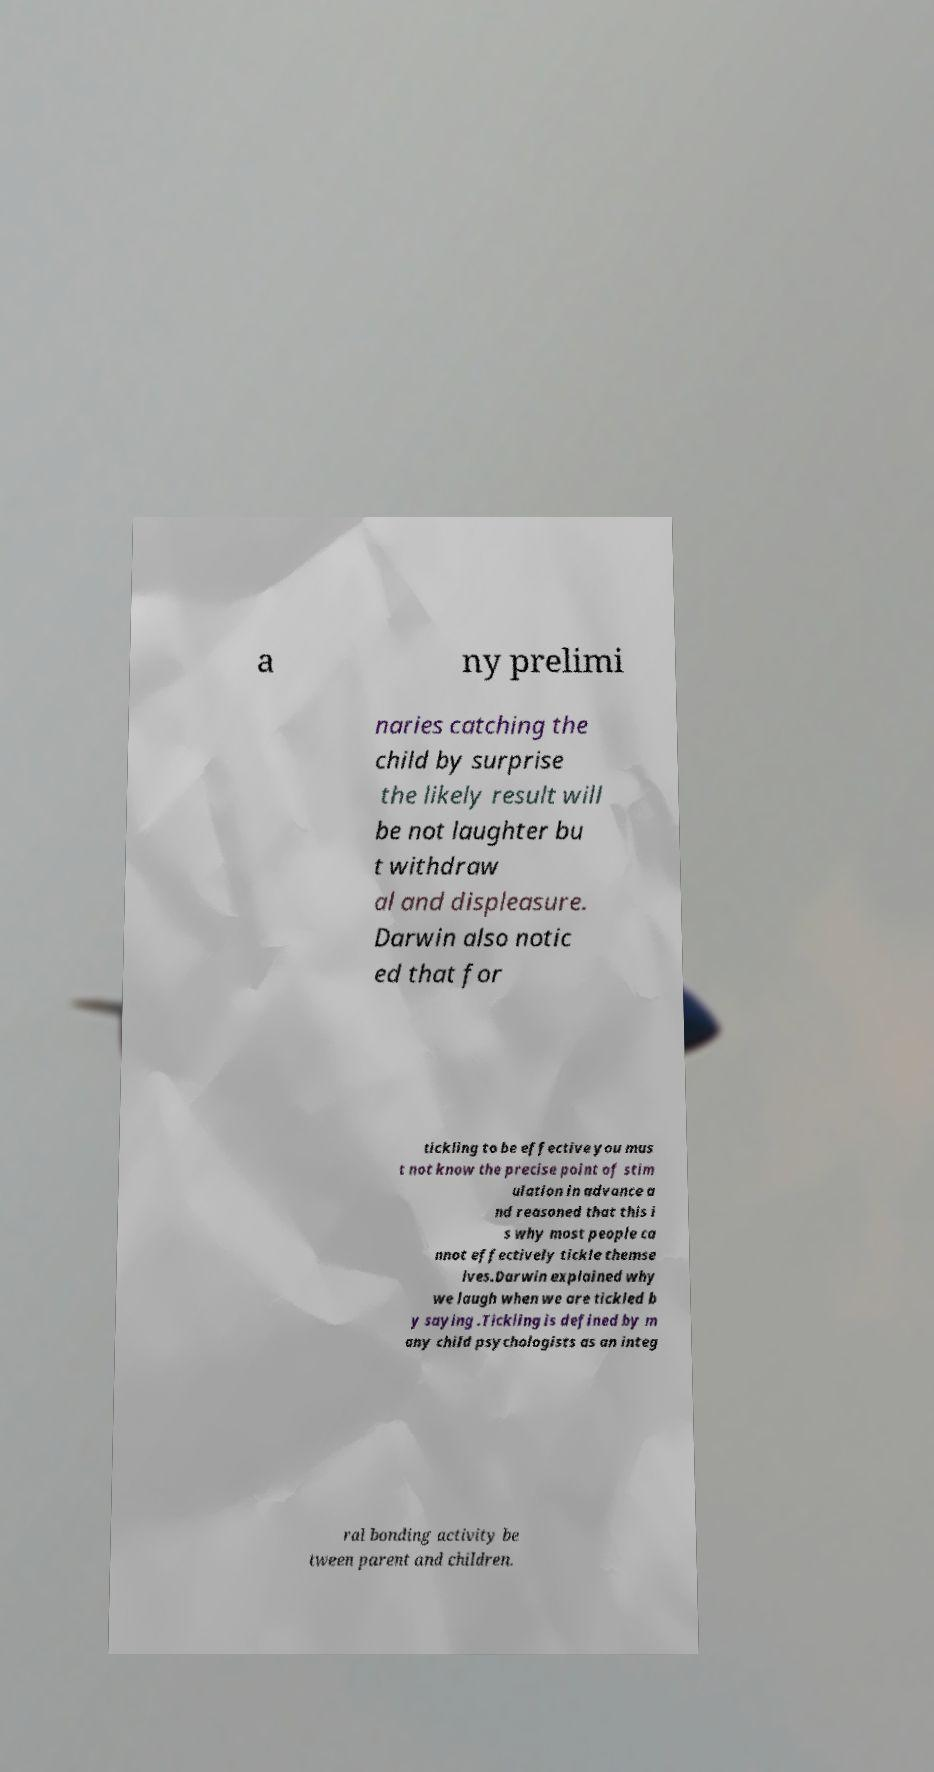Could you extract and type out the text from this image? a ny prelimi naries catching the child by surprise the likely result will be not laughter bu t withdraw al and displeasure. Darwin also notic ed that for tickling to be effective you mus t not know the precise point of stim ulation in advance a nd reasoned that this i s why most people ca nnot effectively tickle themse lves.Darwin explained why we laugh when we are tickled b y saying .Tickling is defined by m any child psychologists as an integ ral bonding activity be tween parent and children. 